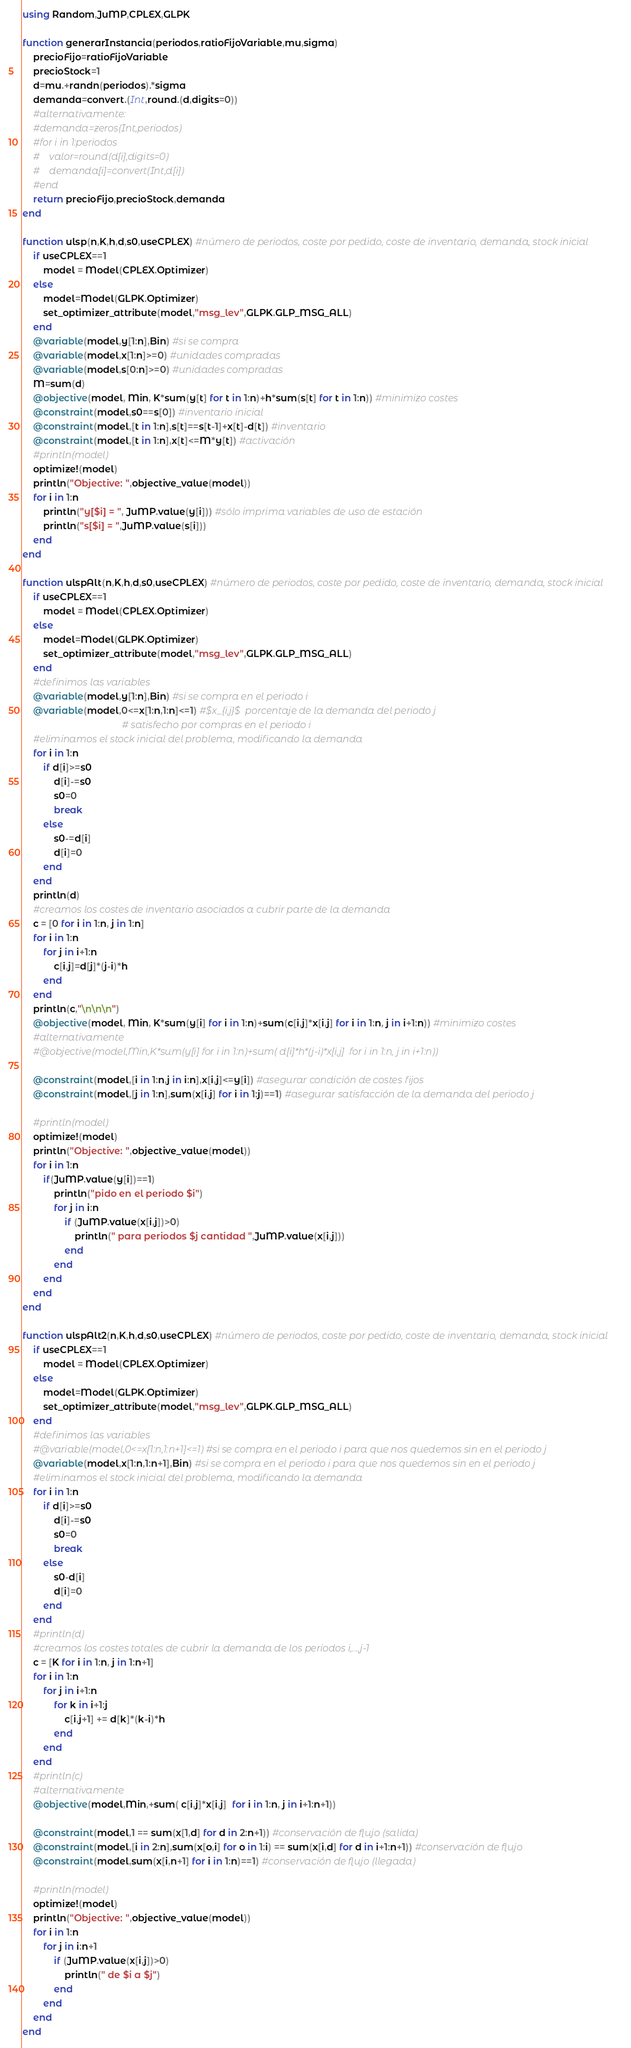<code> <loc_0><loc_0><loc_500><loc_500><_Julia_>using Random,JuMP,CPLEX,GLPK

function generarInstancia(periodos,ratioFijoVariable,mu,sigma)
    precioFijo=ratioFijoVariable
    precioStock=1
    d=mu.+randn(periodos).*sigma
    demanda=convert.(Int,round.(d,digits=0))
    #alternativamente:
    #demanda=zeros(Int,periodos)
    #for i in 1:periodos
    #    valor=round(d[i],digits=0)
    #    demanda[i]=convert(Int,d[i])
    #end
    return precioFijo,precioStock,demanda
end

function ulsp(n,K,h,d,s0,useCPLEX) #número de periodos, coste por pedido, coste de inventario, demanda, stock inicial
    if useCPLEX==1
        model = Model(CPLEX.Optimizer)
    else
        model=Model(GLPK.Optimizer)
        set_optimizer_attribute(model,"msg_lev",GLPK.GLP_MSG_ALL)
    end
    @variable(model,y[1:n],Bin) #si se compra
    @variable(model,x[1:n]>=0) #unidades compradas
    @variable(model,s[0:n]>=0) #unidades compradas
    M=sum(d)
    @objective(model, Min, K*sum(y[t] for t in 1:n)+h*sum(s[t] for t in 1:n)) #minimizo costes
    @constraint(model,s0==s[0]) #inventario inicial
    @constraint(model,[t in 1:n],s[t]==s[t-1]+x[t]-d[t]) #inventario
    @constraint(model,[t in 1:n],x[t]<=M*y[t]) #activación
    #println(model)
    optimize!(model)
    println("Objective: ",objective_value(model))
    for i in 1:n
        println("y[$i] = ", JuMP.value(y[i])) #sólo imprima variables de uso de estación
        println("s[$i] = ",JuMP.value(s[i]))
    end
end

function ulspAlt(n,K,h,d,s0,useCPLEX) #número de periodos, coste por pedido, coste de inventario, demanda, stock inicial
    if useCPLEX==1
        model = Model(CPLEX.Optimizer)
    else
        model=Model(GLPK.Optimizer)
        set_optimizer_attribute(model,"msg_lev",GLPK.GLP_MSG_ALL)
    end
    #definimos las variables
    @variable(model,y[1:n],Bin) #si se compra en el periodo i
    @variable(model,0<=x[1:n,1:n]<=1) #$x_{i,j}$  porcentaje de la demanda del periodo j
                                      # satisfecho por compras en el periodo i
    #eliminamos el stock inicial del problema, modificando la demanda
    for i in 1:n
        if d[i]>=s0
            d[i]-=s0
            s0=0
            break
        else
            s0-=d[i]
            d[i]=0
        end
    end
    println(d)
    #creamos los costes de inventario asociados a cubrir parte de la demanda
    c = [0 for i in 1:n, j in 1:n]
    for i in 1:n
        for j in i+1:n
            c[i,j]=d[j]*(j-i)*h
        end
    end
    println(c,"\n\n\n")
    @objective(model, Min, K*sum(y[i] for i in 1:n)+sum(c[i,j]*x[i,j] for i in 1:n, j in i+1:n)) #minimizo costes
    #alternativamente
    #@objective(model,Min,K*sum(y[i] for i in 1:n)+sum( d[i]*h*(j-i)*x[i,j]  for i in 1:n, j in i+1:n))

    @constraint(model,[i in 1:n,j in i:n],x[i,j]<=y[i]) #asegurar condición de costes fijos
    @constraint(model,[j in 1:n],sum(x[i,j] for i in 1:j)==1) #asegurar satisfacción de la demanda del periodo j

    #println(model)
    optimize!(model)
    println("Objective: ",objective_value(model))
    for i in 1:n
        if(JuMP.value(y[i])==1)
            println("pido en el periodo $i")
            for j in i:n
                if (JuMP.value(x[i,j])>0)
                    println(" para periodos $j cantidad ",JuMP.value(x[i,j]))
                end
            end
        end
    end
end

function ulspAlt2(n,K,h,d,s0,useCPLEX) #número de periodos, coste por pedido, coste de inventario, demanda, stock inicial
    if useCPLEX==1
        model = Model(CPLEX.Optimizer)
    else
        model=Model(GLPK.Optimizer)
        set_optimizer_attribute(model,"msg_lev",GLPK.GLP_MSG_ALL)
    end
    #definimos las variables
    #@variable(model,0<=x[1:n,1:n+1]<=1) #si se compra en el periodo i para que nos quedemos sin en el periodo j
    @variable(model,x[1:n,1:n+1],Bin) #si se compra en el periodo i para que nos quedemos sin en el periodo j
    #eliminamos el stock inicial del problema, modificando la demanda
    for i in 1:n
        if d[i]>=s0
            d[i]-=s0
            s0=0
            break
        else
            s0-d[i]
            d[i]=0
        end
    end
    #println(d)
    #creamos los costes totales de cubrir la demanda de los periodos i,...,j-1
    c = [K for i in 1:n, j in 1:n+1]
    for i in 1:n
        for j in i+1:n
            for k in i+1:j
                c[i,j+1] += d[k]*(k-i)*h
            end
        end
    end
    #println(c)
    #alternativamente
    @objective(model,Min,+sum( c[i,j]*x[i,j]  for i in 1:n, j in i+1:n+1))

    @constraint(model,1 == sum(x[1,d] for d in 2:n+1)) #conservación de flujo (salida)
    @constraint(model,[i in 2:n],sum(x[o,i] for o in 1:i) == sum(x[i,d] for d in i+1:n+1)) #conservación de flujo
    @constraint(model,sum(x[i,n+1] for i in 1:n)==1) #conservación de flujo (llegada)

    #println(model)
    optimize!(model)
    println("Objective: ",objective_value(model))
    for i in 1:n
        for j in i:n+1
            if (JuMP.value(x[i,j])>0)
                println(" de $i a $j")
            end
        end
    end
end

</code> 